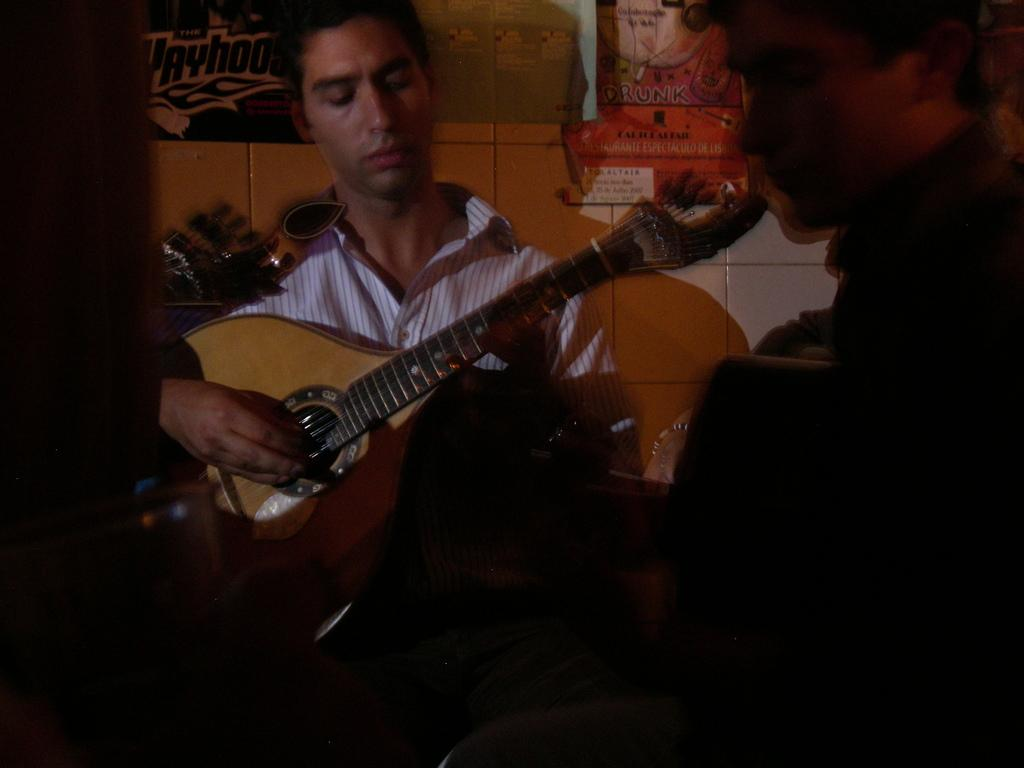How many people are in the image? There are two persons in the image. What are the persons doing in the image? The persons are sitting and holding guitars. What can be seen in the background of the image? There is a wall in the background of the image. What type of hammer can be seen in the image? There is no hammer present in the image. Is there any snow visible in the image? There is no snow visible in the image. 